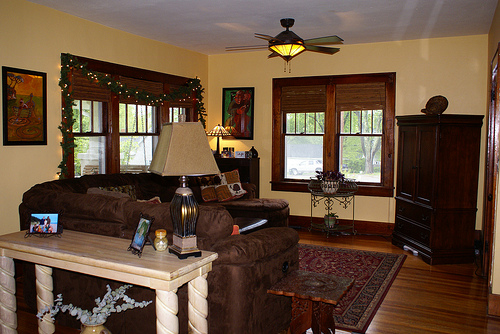Please provide a short description for this region: [0.39, 0.5, 0.5, 0.58]. Decorative pillows placed neatly on a comfortable couch. 